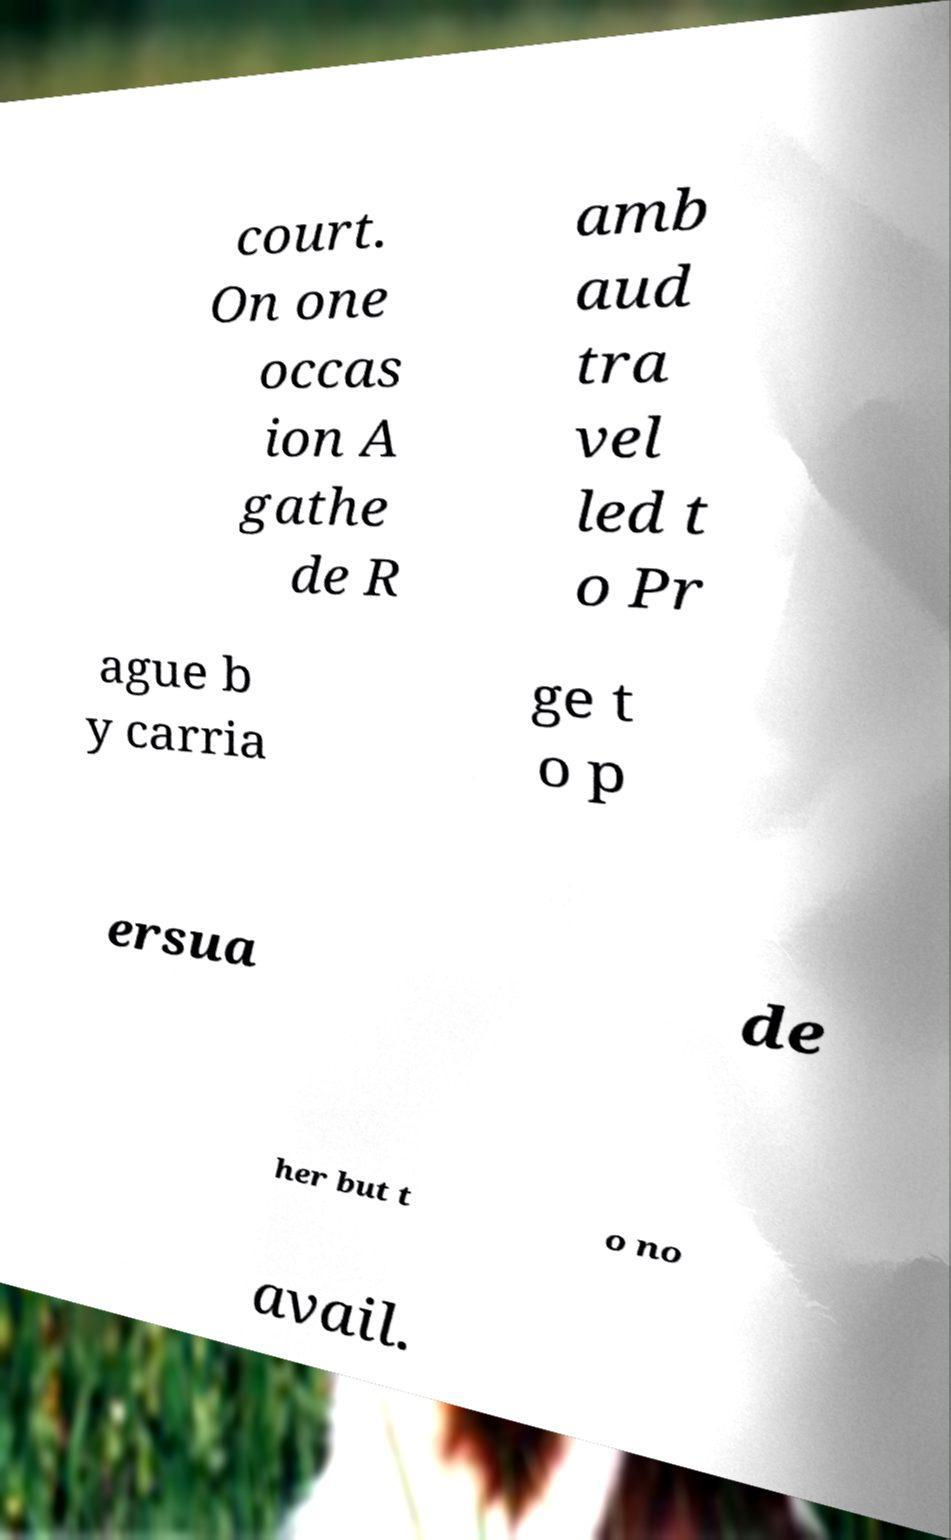Please identify and transcribe the text found in this image. court. On one occas ion A gathe de R amb aud tra vel led t o Pr ague b y carria ge t o p ersua de her but t o no avail. 